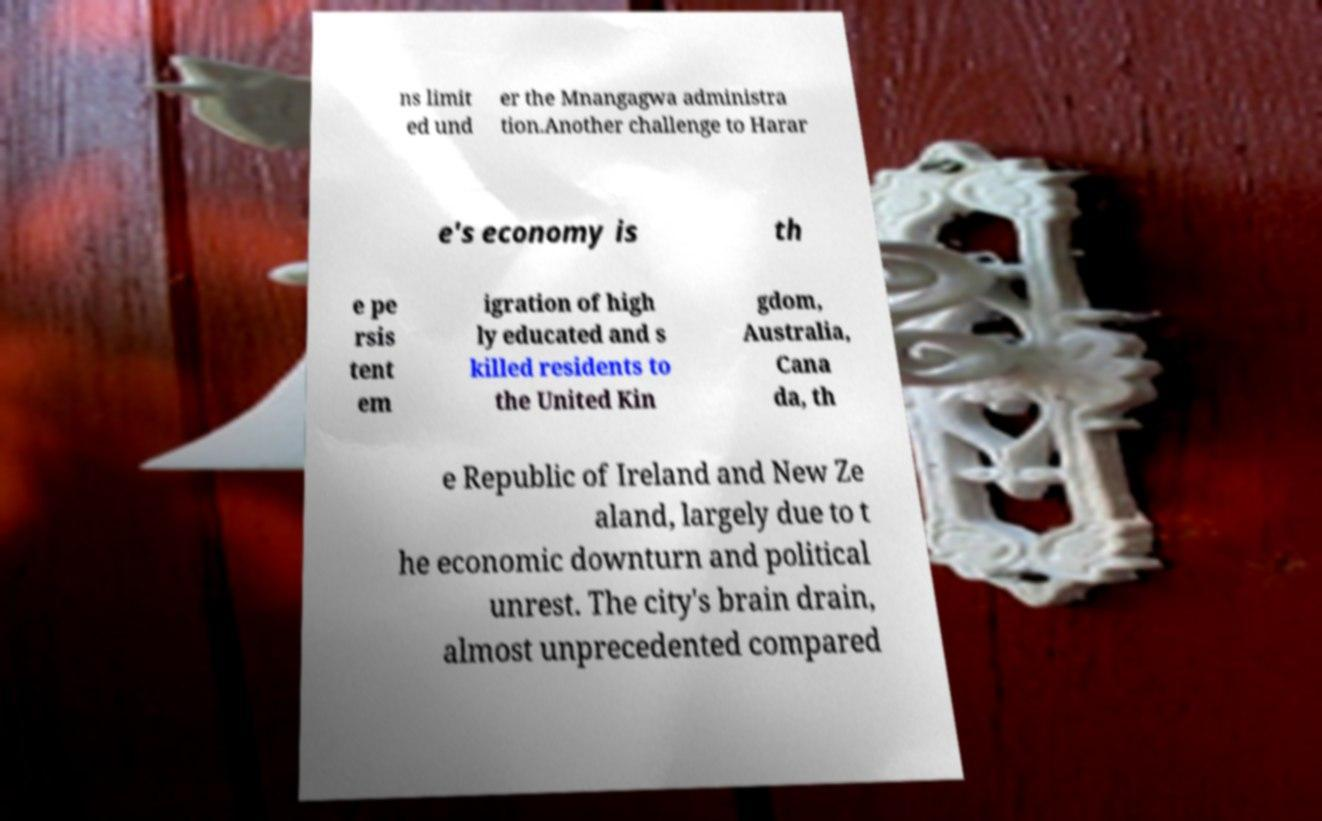For documentation purposes, I need the text within this image transcribed. Could you provide that? ns limit ed und er the Mnangagwa administra tion.Another challenge to Harar e's economy is th e pe rsis tent em igration of high ly educated and s killed residents to the United Kin gdom, Australia, Cana da, th e Republic of Ireland and New Ze aland, largely due to t he economic downturn and political unrest. The city's brain drain, almost unprecedented compared 